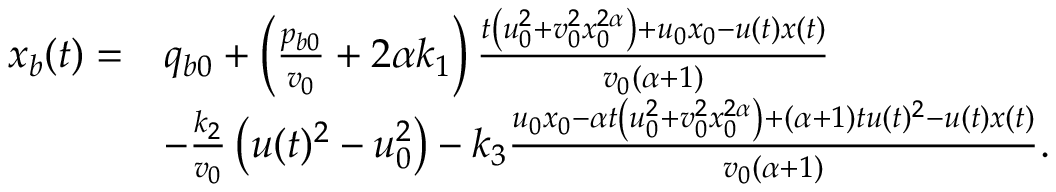<formula> <loc_0><loc_0><loc_500><loc_500>\begin{array} { r l } { x _ { b } ( t ) = } & { q _ { b 0 } + \left ( \frac { p _ { b 0 } } { v _ { 0 } } + 2 \alpha k _ { 1 } \right ) \frac { t \left ( u _ { 0 } ^ { 2 } + v _ { 0 } ^ { 2 } x _ { 0 } ^ { 2 \alpha } \right ) + u _ { 0 } x _ { 0 } - u ( t ) x ( t ) } { v _ { 0 } ( \alpha + 1 ) } } \\ & { - \frac { k _ { 2 } } { v _ { 0 } } \left ( u ( t ) ^ { 2 } - u _ { 0 } ^ { 2 } \right ) - k _ { 3 } \frac { u _ { 0 } x _ { 0 } - \alpha t \left ( u _ { 0 } ^ { 2 } + v _ { 0 } ^ { 2 } x _ { 0 } ^ { 2 \alpha } \right ) + ( \alpha + 1 ) t u ( t ) ^ { 2 } - u ( t ) x ( t ) } { v _ { 0 } ( \alpha + 1 ) } . } \end{array}</formula> 